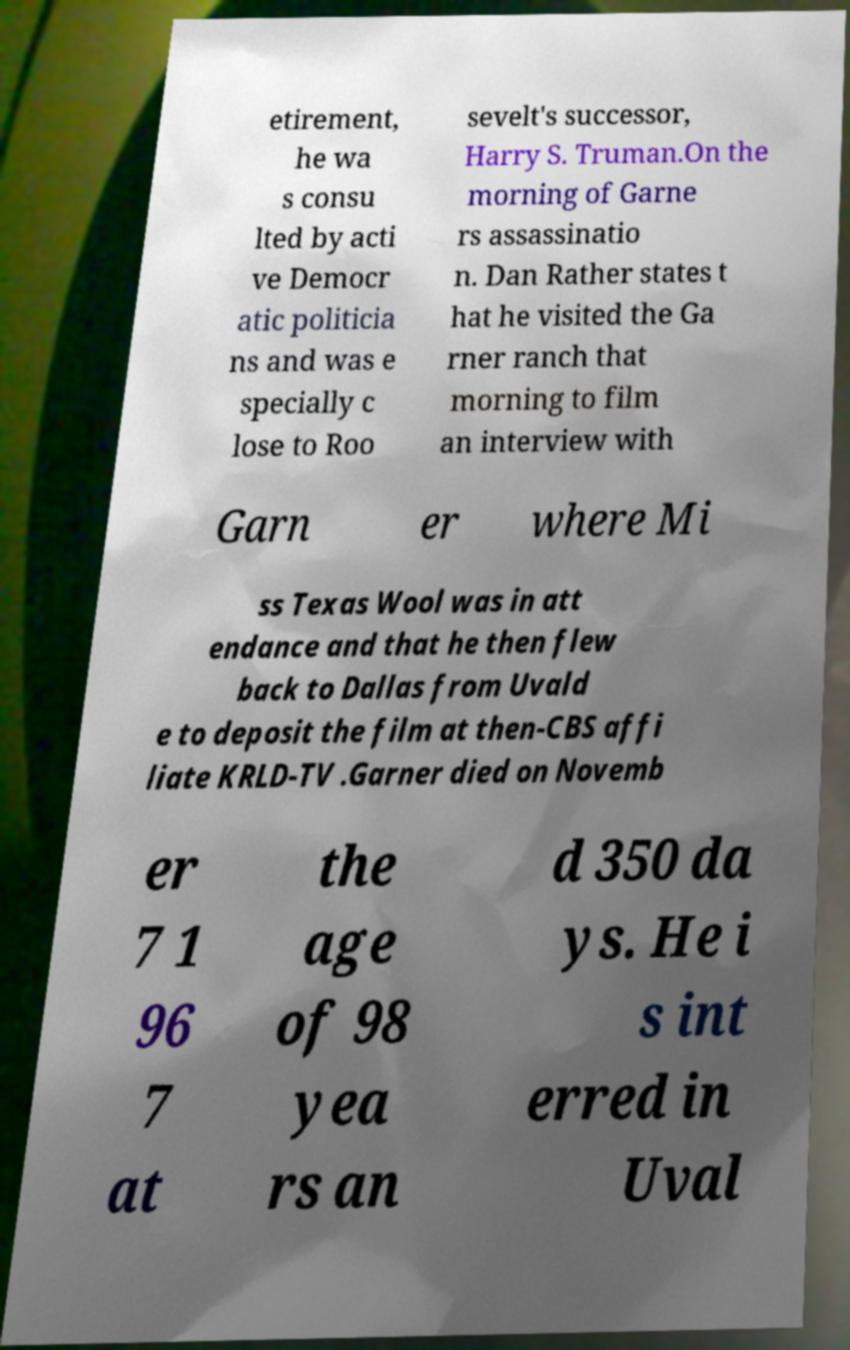Can you read and provide the text displayed in the image?This photo seems to have some interesting text. Can you extract and type it out for me? etirement, he wa s consu lted by acti ve Democr atic politicia ns and was e specially c lose to Roo sevelt's successor, Harry S. Truman.On the morning of Garne rs assassinatio n. Dan Rather states t hat he visited the Ga rner ranch that morning to film an interview with Garn er where Mi ss Texas Wool was in att endance and that he then flew back to Dallas from Uvald e to deposit the film at then-CBS affi liate KRLD-TV .Garner died on Novemb er 7 1 96 7 at the age of 98 yea rs an d 350 da ys. He i s int erred in Uval 